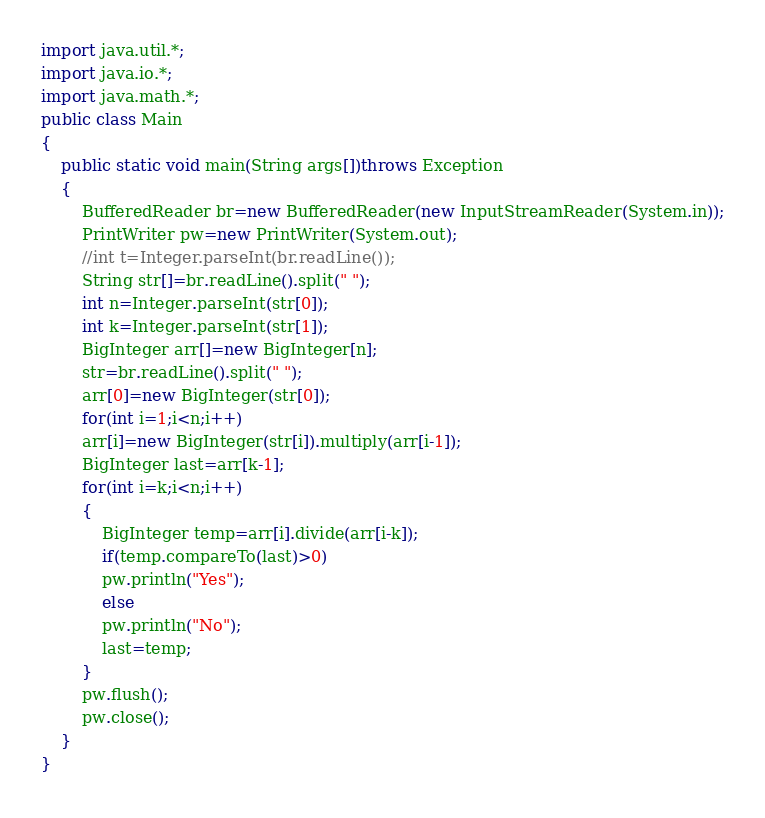<code> <loc_0><loc_0><loc_500><loc_500><_Java_>import java.util.*;
import java.io.*;
import java.math.*;
public class Main
{
    public static void main(String args[])throws Exception
    {
        BufferedReader br=new BufferedReader(new InputStreamReader(System.in));
        PrintWriter pw=new PrintWriter(System.out);
        //int t=Integer.parseInt(br.readLine());
        String str[]=br.readLine().split(" ");
        int n=Integer.parseInt(str[0]);
        int k=Integer.parseInt(str[1]);
        BigInteger arr[]=new BigInteger[n];
        str=br.readLine().split(" ");
        arr[0]=new BigInteger(str[0]);
        for(int i=1;i<n;i++)
        arr[i]=new BigInteger(str[i]).multiply(arr[i-1]);
        BigInteger last=arr[k-1];
        for(int i=k;i<n;i++)
        {
            BigInteger temp=arr[i].divide(arr[i-k]);
            if(temp.compareTo(last)>0)
            pw.println("Yes");
            else
            pw.println("No");
            last=temp;
        }
        pw.flush();
        pw.close();
    }
}</code> 